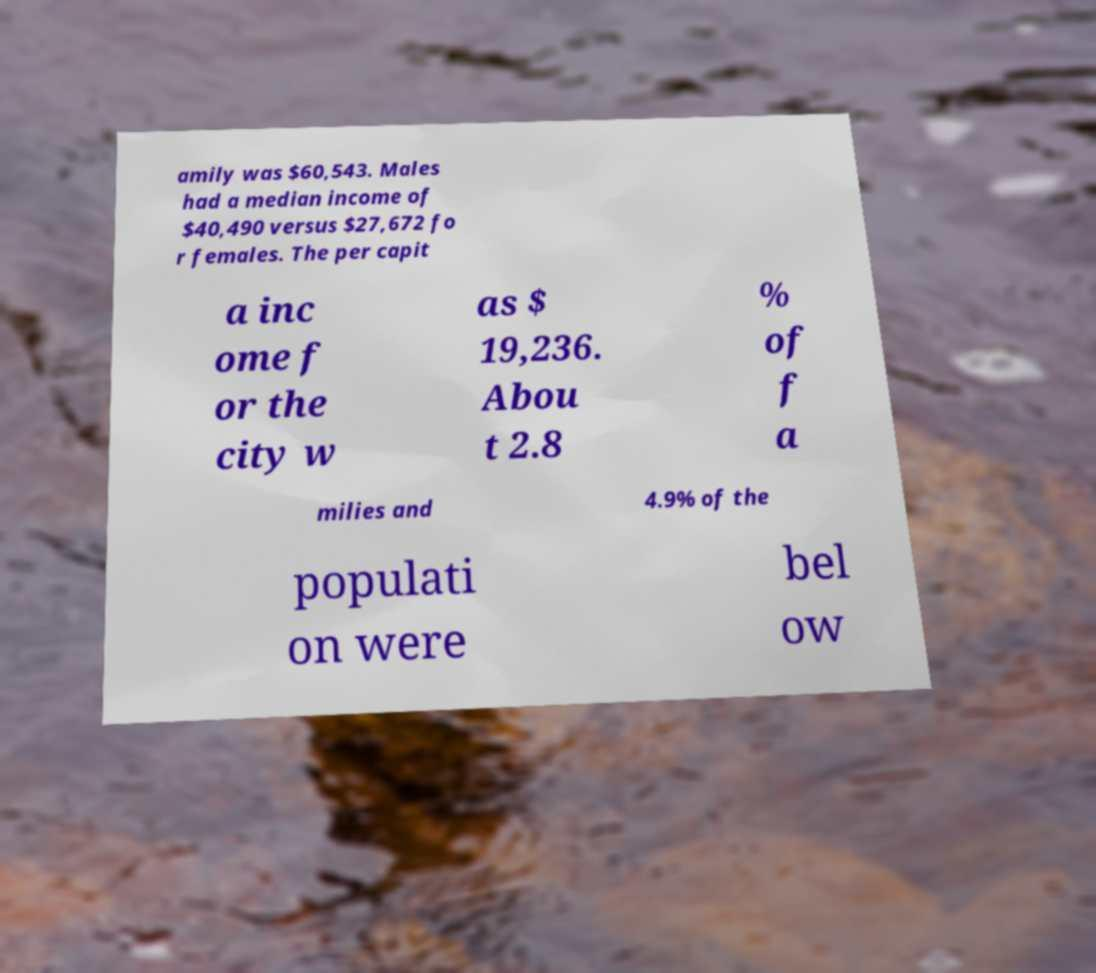I need the written content from this picture converted into text. Can you do that? amily was $60,543. Males had a median income of $40,490 versus $27,672 fo r females. The per capit a inc ome f or the city w as $ 19,236. Abou t 2.8 % of f a milies and 4.9% of the populati on were bel ow 